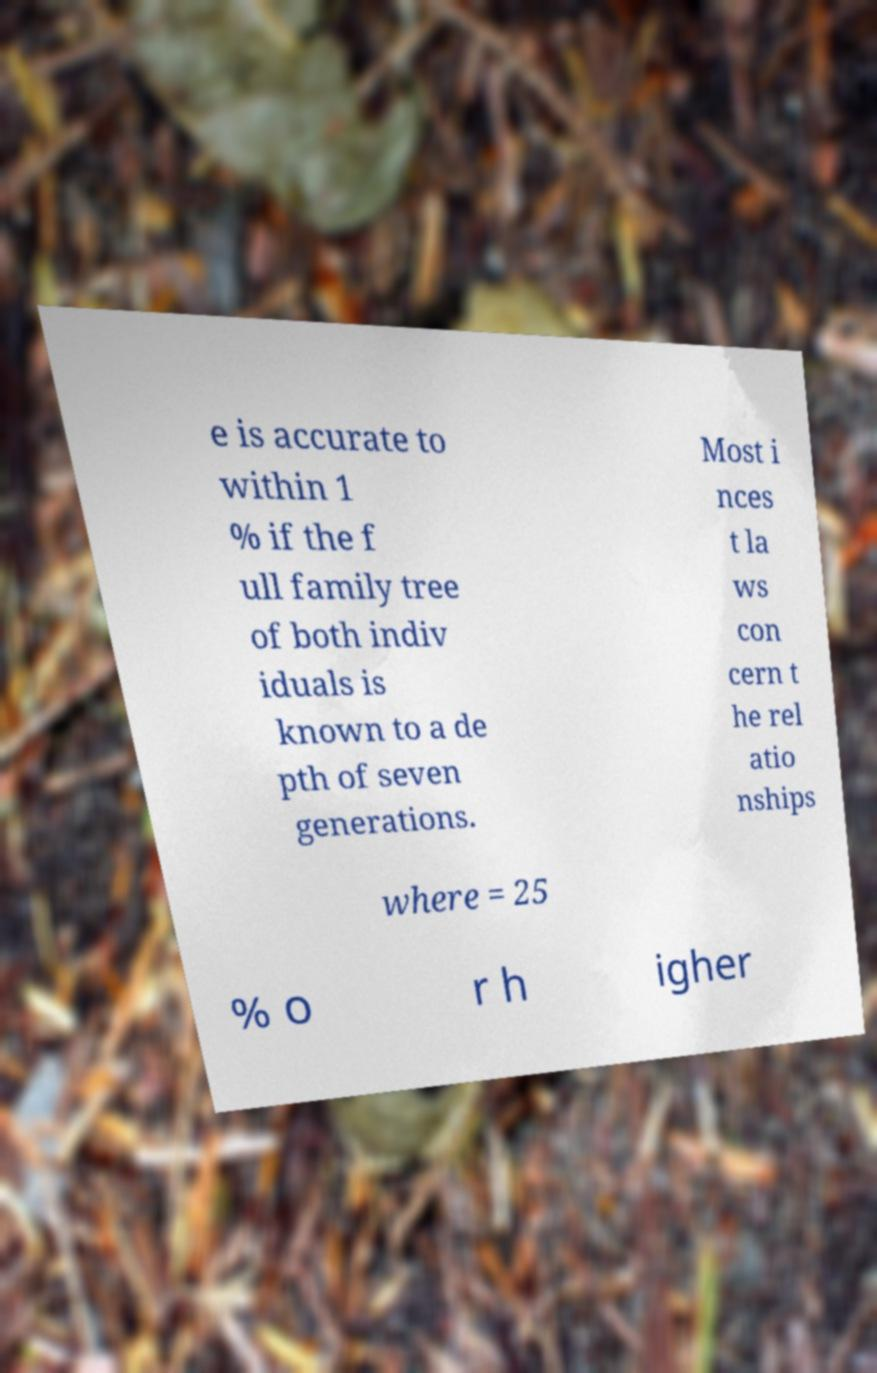I need the written content from this picture converted into text. Can you do that? e is accurate to within 1 % if the f ull family tree of both indiv iduals is known to a de pth of seven generations. Most i nces t la ws con cern t he rel atio nships where = 25 % o r h igher 